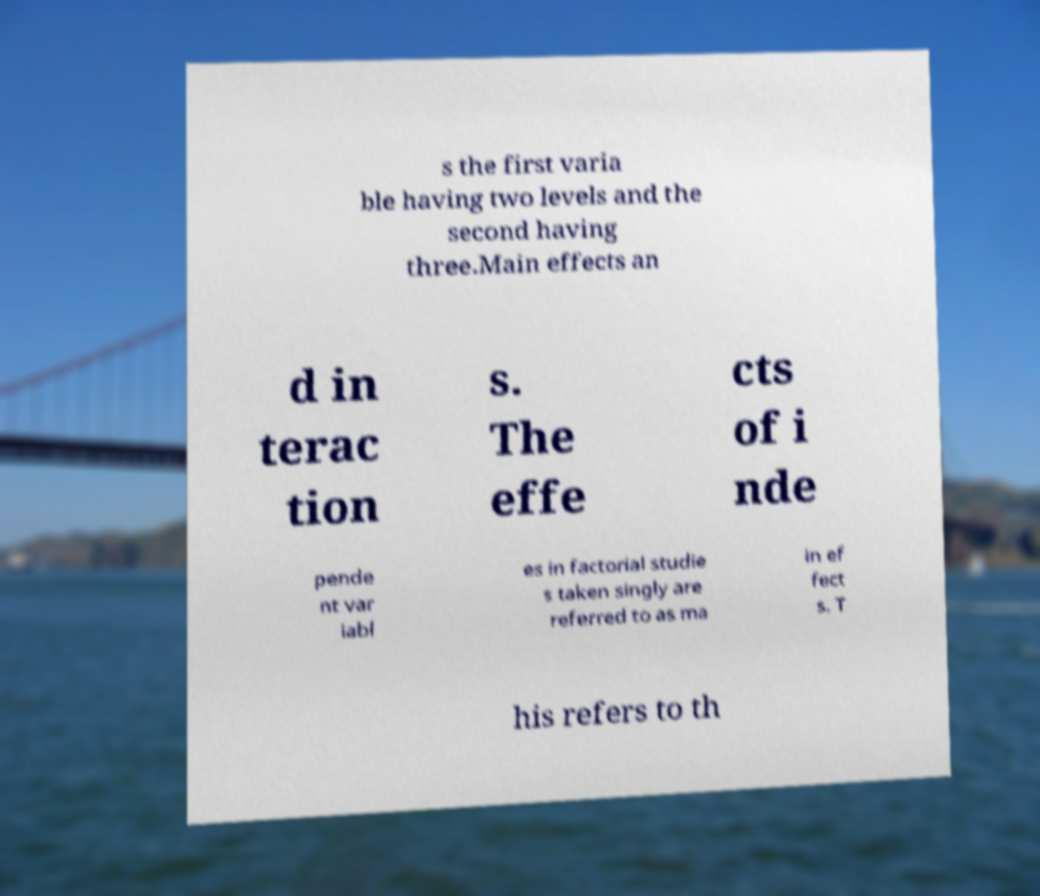There's text embedded in this image that I need extracted. Can you transcribe it verbatim? s the first varia ble having two levels and the second having three.Main effects an d in terac tion s. The effe cts of i nde pende nt var iabl es in factorial studie s taken singly are referred to as ma in ef fect s. T his refers to th 